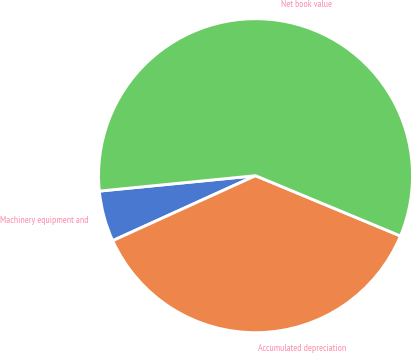Convert chart. <chart><loc_0><loc_0><loc_500><loc_500><pie_chart><fcel>Machinery equipment and<fcel>Accumulated depreciation<fcel>Net book value<nl><fcel>5.23%<fcel>36.93%<fcel>57.84%<nl></chart> 